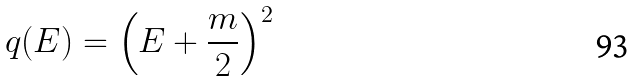<formula> <loc_0><loc_0><loc_500><loc_500>q ( E ) = \left ( E + \frac { m } { 2 } \right ) ^ { 2 }</formula> 